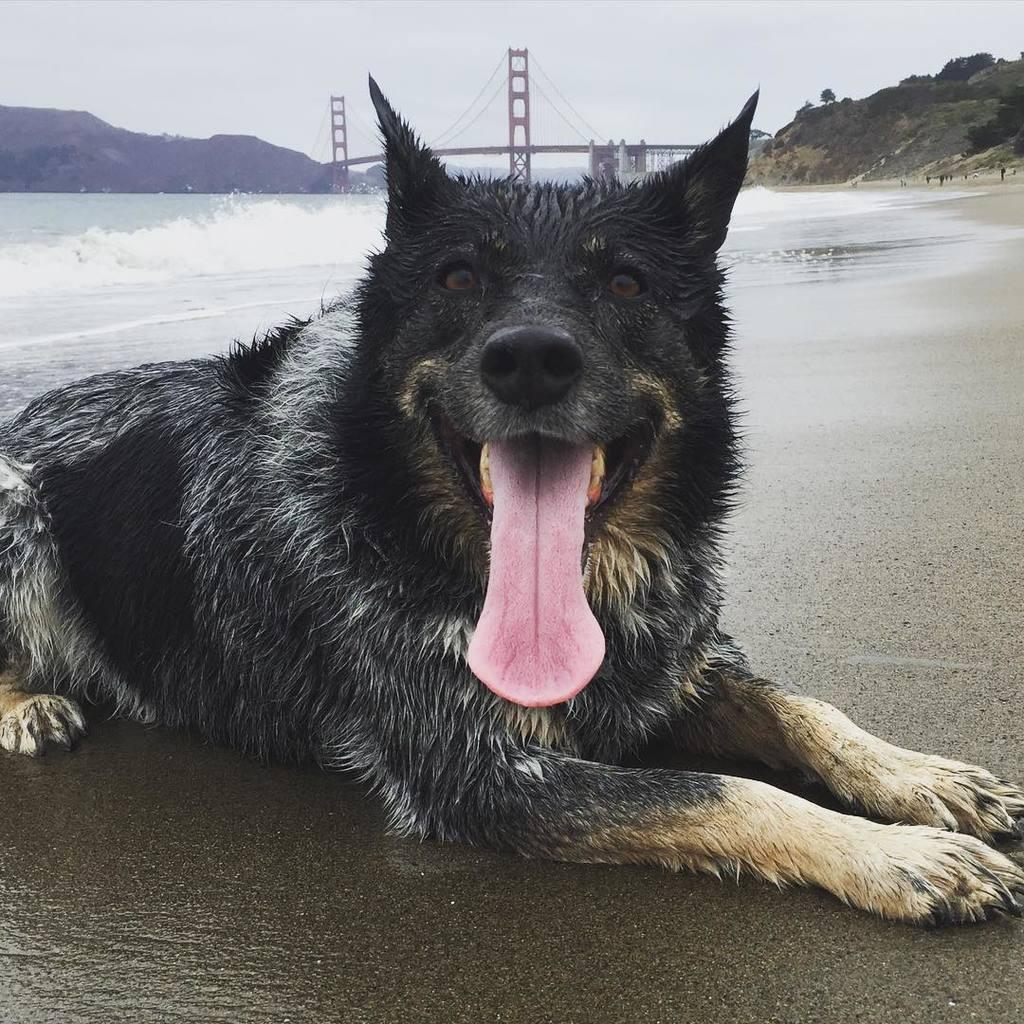What is the main setting of the image? There is an open ground in the image. What animal can be seen on the open ground? There is a black-colored dog on the open ground. What can be seen in the background of the image? Water, mountains, and the sky are visible in the background of the image. Is there any man-made structure visible in the background? Yes, there is a bridge over the water in the background of the image. How many turkeys are present in the image? There are no turkeys present in the image. What is the temper of the giants in the image? There are no giants present in the image. 